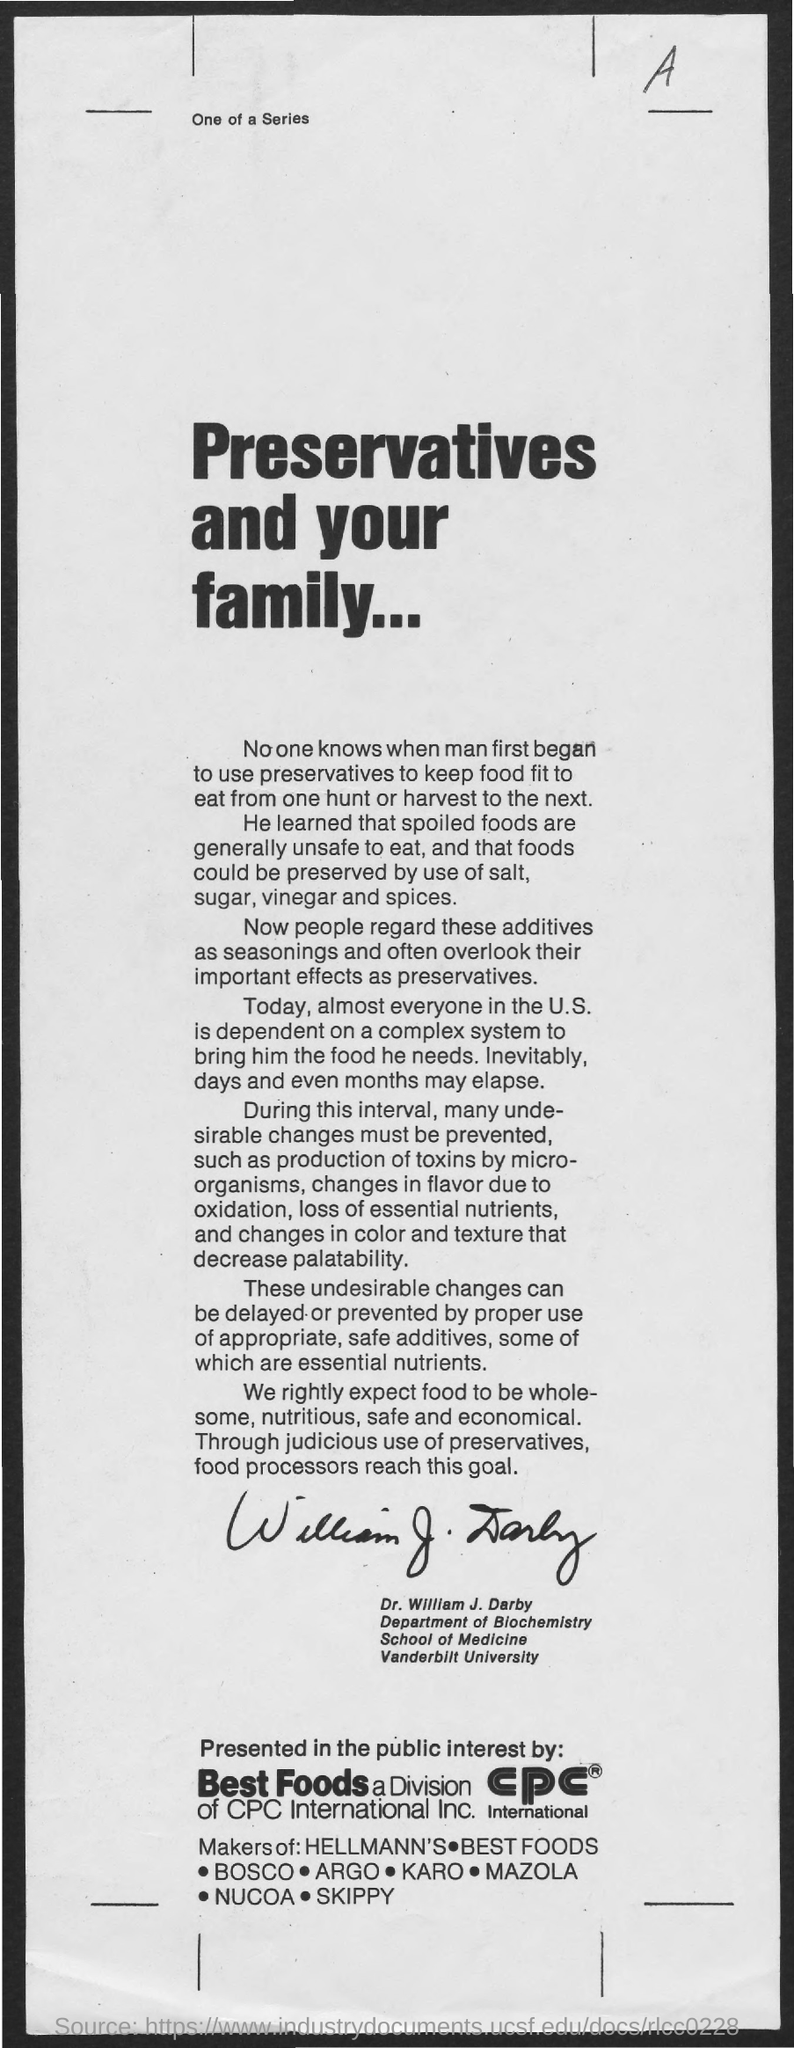List a handful of essential elements in this visual. William J. Darby is a student at Vanderbilt University. The main title of this document is 'Preservatives and Your Family'. The individual known as William J. Darby is affiliated with the Department of Biochemistry. The letter that is located at the top-right corner of the document is A. 